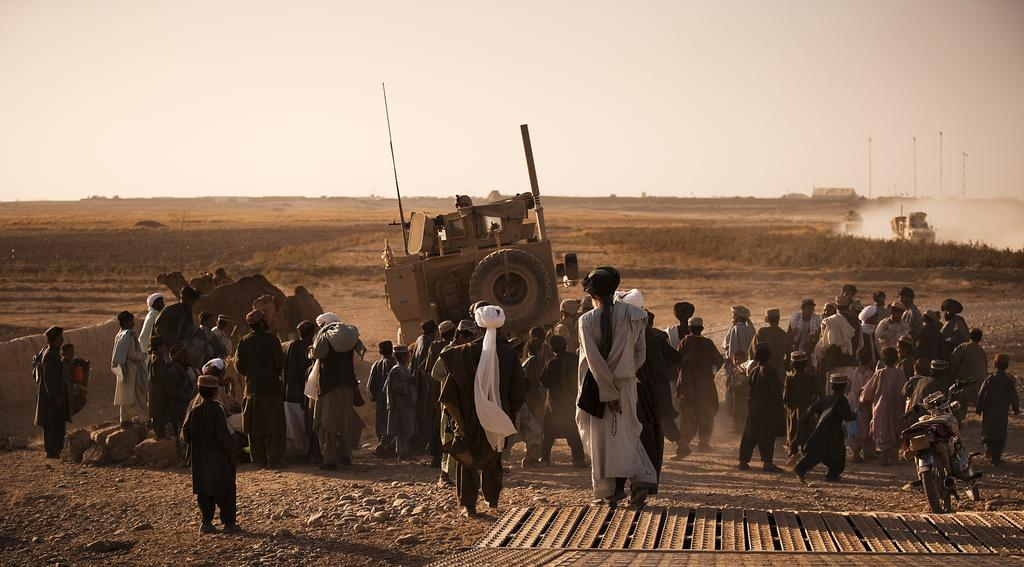What is the main setting of the image? There are people standing on a land in the image. What can be seen in front of the people? There are vehicles in front of the people. What is visible in the background of the image? There are poles and the sky visible in the background of the image. Can you describe an object in the bottom right corner of the image? There is a metal sheet in the bottom right corner of the image. What type of list can be seen on the faces of the people in the image? There is no list visible on the faces of the people in the image. Can you tell me the credit score of the person standing on the left in the image? There is no information about credit scores in the image. 